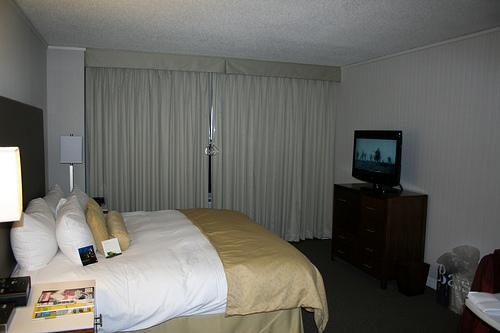Determine the emotion or sentiment that the image conveys. The image conveys a calm and peaceful atmosphere in the bedroom. What items can be found on the nightstand? Magazines and a black alarm clock are on the nightstand. Identify the dominant color of the wall in the image. The wall is predominantly white. Name an object that seems out of place or unusual in the given context. A bass store shopping bag seems slightly out of place in the bedroom scene. List the items that can be found on or near the bed. White pillows, tan bed coverings and a small dark trashcan are near the bed. Describe what the television set looks like. The television set has a black frame, and it is turned on. Explain the overall context of the image. This is a picture of a bedroom with various furniture items like a bed, dresser, and windows with curtains. 